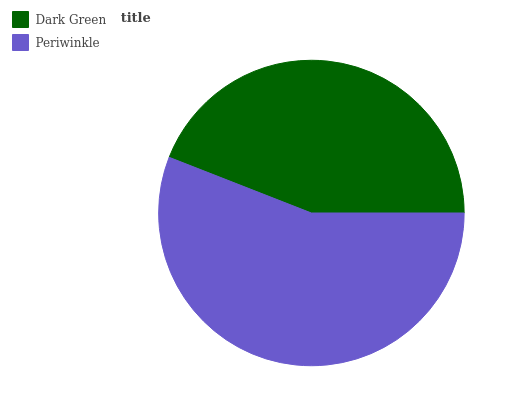Is Dark Green the minimum?
Answer yes or no. Yes. Is Periwinkle the maximum?
Answer yes or no. Yes. Is Periwinkle the minimum?
Answer yes or no. No. Is Periwinkle greater than Dark Green?
Answer yes or no. Yes. Is Dark Green less than Periwinkle?
Answer yes or no. Yes. Is Dark Green greater than Periwinkle?
Answer yes or no. No. Is Periwinkle less than Dark Green?
Answer yes or no. No. Is Periwinkle the high median?
Answer yes or no. Yes. Is Dark Green the low median?
Answer yes or no. Yes. Is Dark Green the high median?
Answer yes or no. No. Is Periwinkle the low median?
Answer yes or no. No. 